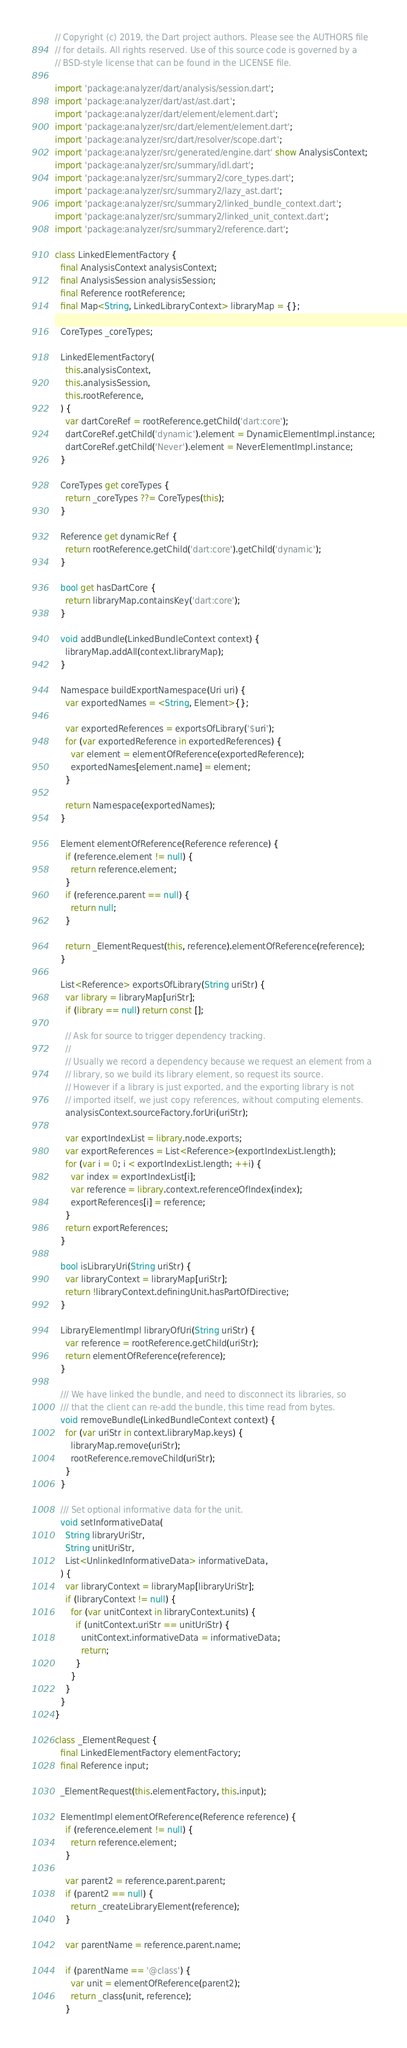<code> <loc_0><loc_0><loc_500><loc_500><_Dart_>// Copyright (c) 2019, the Dart project authors. Please see the AUTHORS file
// for details. All rights reserved. Use of this source code is governed by a
// BSD-style license that can be found in the LICENSE file.

import 'package:analyzer/dart/analysis/session.dart';
import 'package:analyzer/dart/ast/ast.dart';
import 'package:analyzer/dart/element/element.dart';
import 'package:analyzer/src/dart/element/element.dart';
import 'package:analyzer/src/dart/resolver/scope.dart';
import 'package:analyzer/src/generated/engine.dart' show AnalysisContext;
import 'package:analyzer/src/summary/idl.dart';
import 'package:analyzer/src/summary2/core_types.dart';
import 'package:analyzer/src/summary2/lazy_ast.dart';
import 'package:analyzer/src/summary2/linked_bundle_context.dart';
import 'package:analyzer/src/summary2/linked_unit_context.dart';
import 'package:analyzer/src/summary2/reference.dart';

class LinkedElementFactory {
  final AnalysisContext analysisContext;
  final AnalysisSession analysisSession;
  final Reference rootReference;
  final Map<String, LinkedLibraryContext> libraryMap = {};

  CoreTypes _coreTypes;

  LinkedElementFactory(
    this.analysisContext,
    this.analysisSession,
    this.rootReference,
  ) {
    var dartCoreRef = rootReference.getChild('dart:core');
    dartCoreRef.getChild('dynamic').element = DynamicElementImpl.instance;
    dartCoreRef.getChild('Never').element = NeverElementImpl.instance;
  }

  CoreTypes get coreTypes {
    return _coreTypes ??= CoreTypes(this);
  }

  Reference get dynamicRef {
    return rootReference.getChild('dart:core').getChild('dynamic');
  }

  bool get hasDartCore {
    return libraryMap.containsKey('dart:core');
  }

  void addBundle(LinkedBundleContext context) {
    libraryMap.addAll(context.libraryMap);
  }

  Namespace buildExportNamespace(Uri uri) {
    var exportedNames = <String, Element>{};

    var exportedReferences = exportsOfLibrary('$uri');
    for (var exportedReference in exportedReferences) {
      var element = elementOfReference(exportedReference);
      exportedNames[element.name] = element;
    }

    return Namespace(exportedNames);
  }

  Element elementOfReference(Reference reference) {
    if (reference.element != null) {
      return reference.element;
    }
    if (reference.parent == null) {
      return null;
    }

    return _ElementRequest(this, reference).elementOfReference(reference);
  }

  List<Reference> exportsOfLibrary(String uriStr) {
    var library = libraryMap[uriStr];
    if (library == null) return const [];

    // Ask for source to trigger dependency tracking.
    //
    // Usually we record a dependency because we request an element from a
    // library, so we build its library element, so request its source.
    // However if a library is just exported, and the exporting library is not
    // imported itself, we just copy references, without computing elements.
    analysisContext.sourceFactory.forUri(uriStr);

    var exportIndexList = library.node.exports;
    var exportReferences = List<Reference>(exportIndexList.length);
    for (var i = 0; i < exportIndexList.length; ++i) {
      var index = exportIndexList[i];
      var reference = library.context.referenceOfIndex(index);
      exportReferences[i] = reference;
    }
    return exportReferences;
  }

  bool isLibraryUri(String uriStr) {
    var libraryContext = libraryMap[uriStr];
    return !libraryContext.definingUnit.hasPartOfDirective;
  }

  LibraryElementImpl libraryOfUri(String uriStr) {
    var reference = rootReference.getChild(uriStr);
    return elementOfReference(reference);
  }

  /// We have linked the bundle, and need to disconnect its libraries, so
  /// that the client can re-add the bundle, this time read from bytes.
  void removeBundle(LinkedBundleContext context) {
    for (var uriStr in context.libraryMap.keys) {
      libraryMap.remove(uriStr);
      rootReference.removeChild(uriStr);
    }
  }

  /// Set optional informative data for the unit.
  void setInformativeData(
    String libraryUriStr,
    String unitUriStr,
    List<UnlinkedInformativeData> informativeData,
  ) {
    var libraryContext = libraryMap[libraryUriStr];
    if (libraryContext != null) {
      for (var unitContext in libraryContext.units) {
        if (unitContext.uriStr == unitUriStr) {
          unitContext.informativeData = informativeData;
          return;
        }
      }
    }
  }
}

class _ElementRequest {
  final LinkedElementFactory elementFactory;
  final Reference input;

  _ElementRequest(this.elementFactory, this.input);

  ElementImpl elementOfReference(Reference reference) {
    if (reference.element != null) {
      return reference.element;
    }

    var parent2 = reference.parent.parent;
    if (parent2 == null) {
      return _createLibraryElement(reference);
    }

    var parentName = reference.parent.name;

    if (parentName == '@class') {
      var unit = elementOfReference(parent2);
      return _class(unit, reference);
    }
</code> 